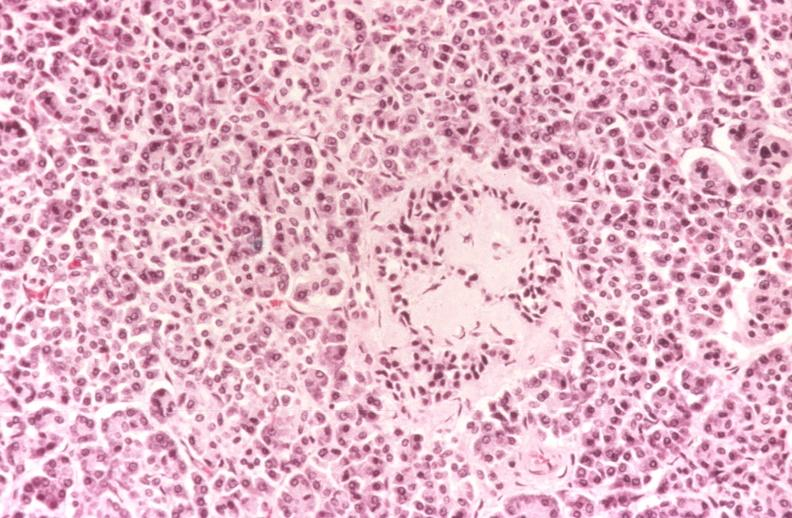does metastatic neuroblastoma show kidney, glomerular amyloid, diabetes mellitus?
Answer the question using a single word or phrase. No 